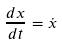Convert formula to latex. <formula><loc_0><loc_0><loc_500><loc_500>\frac { d x } { d t } = \dot { x }</formula> 